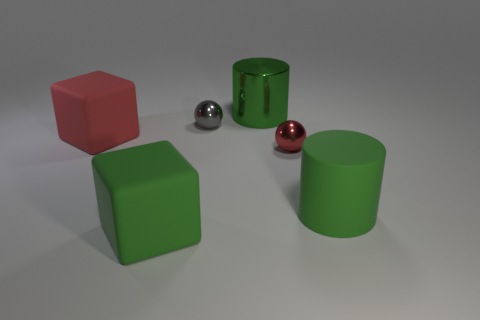There is a rubber object that is the same color as the large rubber cylinder; what is its shape? The rubber object sharing the same color as the large cylinder is a small sphere. 